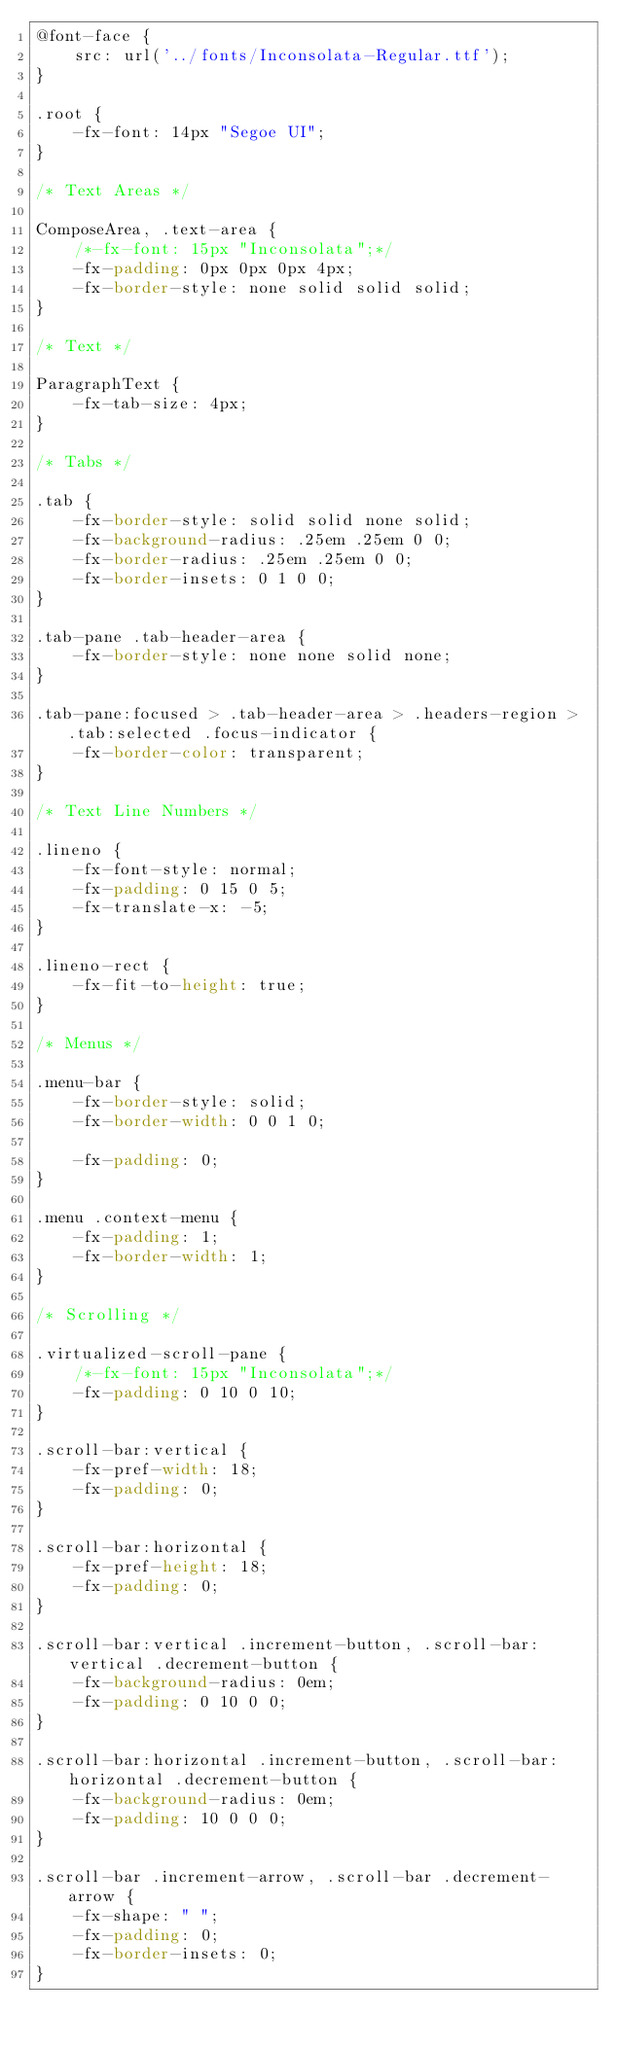Convert code to text. <code><loc_0><loc_0><loc_500><loc_500><_CSS_>@font-face {
    src: url('../fonts/Inconsolata-Regular.ttf');
}

.root {
    -fx-font: 14px "Segoe UI";
}

/* Text Areas */

ComposeArea, .text-area {
    /*-fx-font: 15px "Inconsolata";*/
    -fx-padding: 0px 0px 0px 4px;
    -fx-border-style: none solid solid solid;
}

/* Text */

ParagraphText {
    -fx-tab-size: 4px;
}

/* Tabs */

.tab {
    -fx-border-style: solid solid none solid;
    -fx-background-radius: .25em .25em 0 0;
    -fx-border-radius: .25em .25em 0 0;
    -fx-border-insets: 0 1 0 0;
}

.tab-pane .tab-header-area {
    -fx-border-style: none none solid none;
}

.tab-pane:focused > .tab-header-area > .headers-region > .tab:selected .focus-indicator {
    -fx-border-color: transparent;
}

/* Text Line Numbers */

.lineno {
    -fx-font-style: normal;
    -fx-padding: 0 15 0 5;
    -fx-translate-x: -5;
}

.lineno-rect {
    -fx-fit-to-height: true;
}

/* Menus */

.menu-bar {
    -fx-border-style: solid;
    -fx-border-width: 0 0 1 0;

    -fx-padding: 0;
}

.menu .context-menu {
    -fx-padding: 1;
    -fx-border-width: 1;
}

/* Scrolling */

.virtualized-scroll-pane {
    /*-fx-font: 15px "Inconsolata";*/
    -fx-padding: 0 10 0 10;
}

.scroll-bar:vertical {
    -fx-pref-width: 18;
    -fx-padding: 0;
}

.scroll-bar:horizontal {
    -fx-pref-height: 18;
    -fx-padding: 0;
}

.scroll-bar:vertical .increment-button, .scroll-bar:vertical .decrement-button {
    -fx-background-radius: 0em;
    -fx-padding: 0 10 0 0;
}

.scroll-bar:horizontal .increment-button, .scroll-bar:horizontal .decrement-button {
    -fx-background-radius: 0em;
    -fx-padding: 10 0 0 0;
}

.scroll-bar .increment-arrow, .scroll-bar .decrement-arrow {
    -fx-shape: " ";
    -fx-padding: 0;
    -fx-border-insets: 0;
}
</code> 